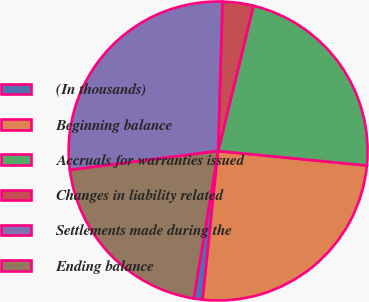<chart> <loc_0><loc_0><loc_500><loc_500><pie_chart><fcel>(In thousands)<fcel>Beginning balance<fcel>Accruals for warranties issued<fcel>Changes in liability related<fcel>Settlements made during the<fcel>Ending balance<nl><fcel>0.96%<fcel>25.11%<fcel>22.74%<fcel>3.34%<fcel>27.49%<fcel>20.36%<nl></chart> 